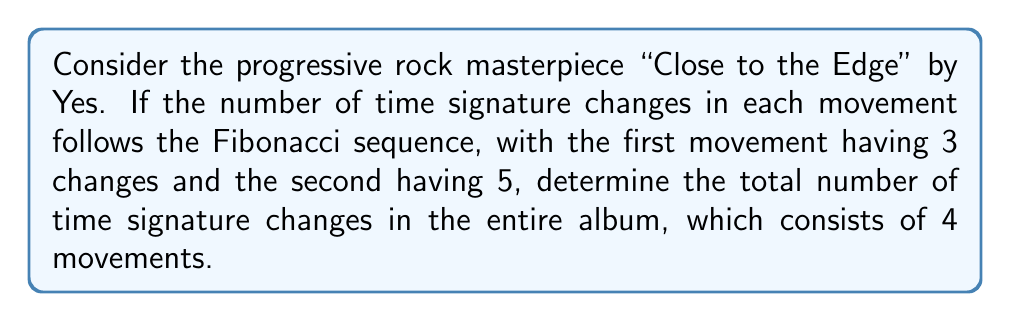Can you solve this math problem? Let's approach this step-by-step:

1) The Fibonacci sequence is defined as:
   $$F_n = F_{n-1} + F_{n-2}$$
   where $F_1 = 1$ and $F_2 = 1$

2) We're given that the first movement has 3 changes and the second has 5. This corresponds to the 4th and 5th Fibonacci numbers:
   $$F_4 = 3, F_5 = 5$$

3) To find the number of changes in the 3rd and 4th movements, we need to continue the sequence:
   $$F_6 = F_5 + F_4 = 5 + 3 = 8$$
   $$F_7 = F_6 + F_5 = 8 + 5 = 13$$

4) Now we have the number of changes for all 4 movements:
   Movement 1: 3
   Movement 2: 5
   Movement 3: 8
   Movement 4: 13

5) To get the total, we sum these numbers:
   $$3 + 5 + 8 + 13 = 29$$

Therefore, the total number of time signature changes in the album is 29.
Answer: 29 